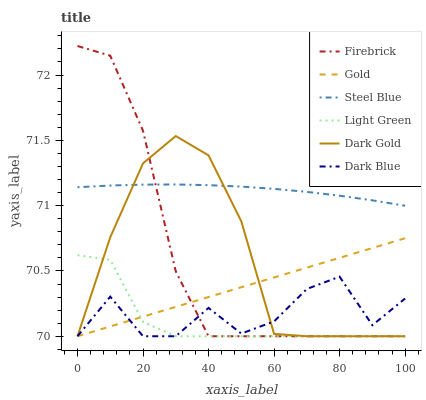Does Light Green have the minimum area under the curve?
Answer yes or no. Yes. Does Steel Blue have the maximum area under the curve?
Answer yes or no. Yes. Does Dark Gold have the minimum area under the curve?
Answer yes or no. No. Does Dark Gold have the maximum area under the curve?
Answer yes or no. No. Is Gold the smoothest?
Answer yes or no. Yes. Is Dark Blue the roughest?
Answer yes or no. Yes. Is Dark Gold the smoothest?
Answer yes or no. No. Is Dark Gold the roughest?
Answer yes or no. No. Does Gold have the lowest value?
Answer yes or no. Yes. Does Steel Blue have the lowest value?
Answer yes or no. No. Does Firebrick have the highest value?
Answer yes or no. Yes. Does Dark Gold have the highest value?
Answer yes or no. No. Is Gold less than Steel Blue?
Answer yes or no. Yes. Is Steel Blue greater than Light Green?
Answer yes or no. Yes. Does Light Green intersect Gold?
Answer yes or no. Yes. Is Light Green less than Gold?
Answer yes or no. No. Is Light Green greater than Gold?
Answer yes or no. No. Does Gold intersect Steel Blue?
Answer yes or no. No. 